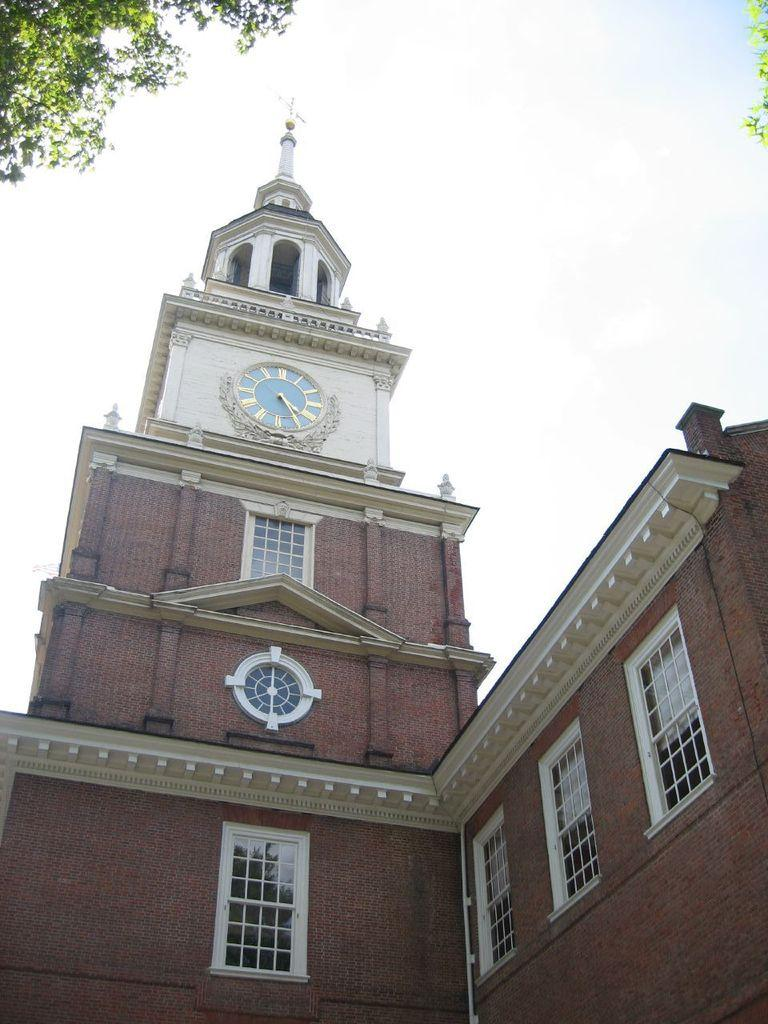What type of structure is in the picture? There is a building in the picture. What feature does the building have? The building has a clock. What else can be observed about the building? The building has windows. What can be seen in the background of the picture? Leaves and the sky are visible in the background of the picture. Where is the calculator located in the picture? There is no calculator present in the picture. Is the crown visible on the building in the picture? There is no crown visible on the building in the picture. 